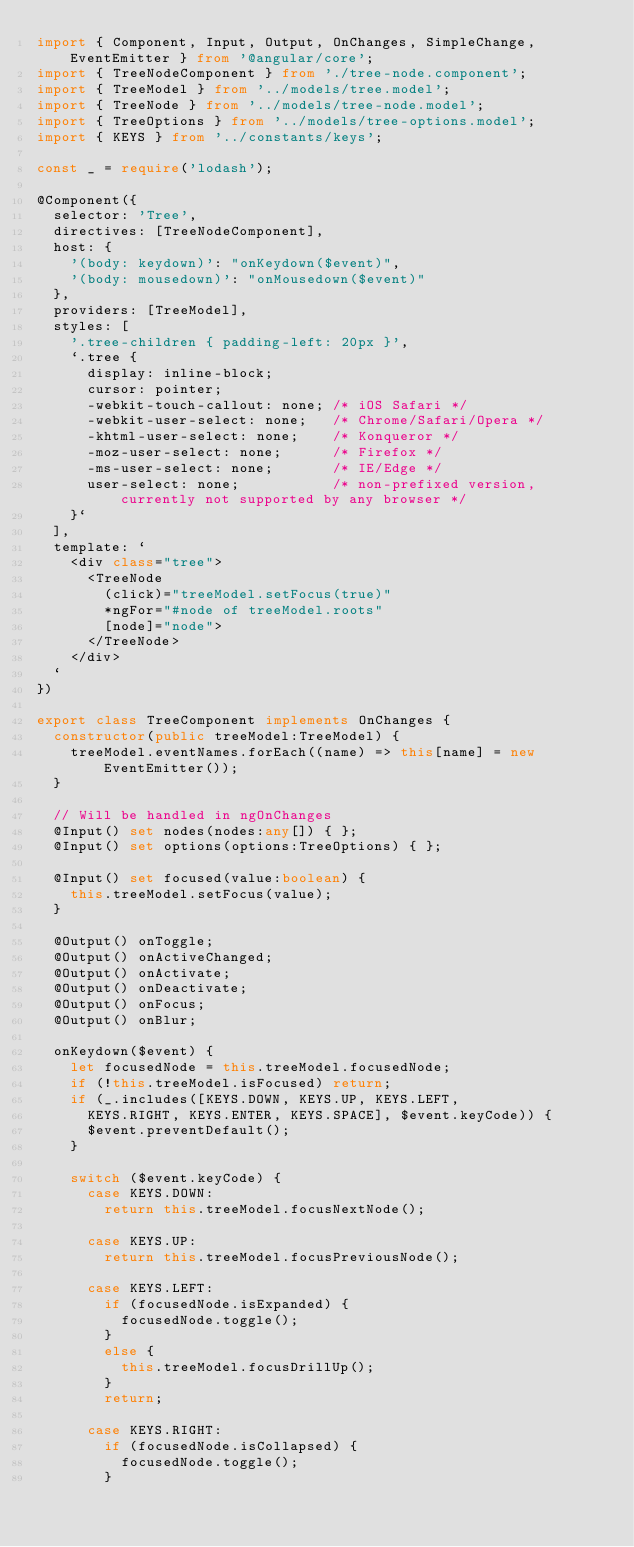Convert code to text. <code><loc_0><loc_0><loc_500><loc_500><_TypeScript_>import { Component, Input, Output, OnChanges, SimpleChange, EventEmitter } from '@angular/core';
import { TreeNodeComponent } from './tree-node.component';
import { TreeModel } from '../models/tree.model';
import { TreeNode } from '../models/tree-node.model';
import { TreeOptions } from '../models/tree-options.model';
import { KEYS } from '../constants/keys';

const _ = require('lodash');

@Component({
  selector: 'Tree',
  directives: [TreeNodeComponent],
  host: {
    '(body: keydown)': "onKeydown($event)",
    '(body: mousedown)': "onMousedown($event)"
  },
  providers: [TreeModel],
  styles: [
    '.tree-children { padding-left: 20px }',
    `.tree {
      display: inline-block;
      cursor: pointer;
      -webkit-touch-callout: none; /* iOS Safari */
      -webkit-user-select: none;   /* Chrome/Safari/Opera */
      -khtml-user-select: none;    /* Konqueror */
      -moz-user-select: none;      /* Firefox */
      -ms-user-select: none;       /* IE/Edge */
      user-select: none;           /* non-prefixed version, currently not supported by any browser */
    }`
  ],
  template: `
    <div class="tree">
      <TreeNode
        (click)="treeModel.setFocus(true)"
        *ngFor="#node of treeModel.roots"
        [node]="node">
      </TreeNode>
    </div>
  `
})

export class TreeComponent implements OnChanges {
  constructor(public treeModel:TreeModel) {
    treeModel.eventNames.forEach((name) => this[name] = new EventEmitter());
  }

  // Will be handled in ngOnChanges
  @Input() set nodes(nodes:any[]) { };
  @Input() set options(options:TreeOptions) { };

  @Input() set focused(value:boolean) {
    this.treeModel.setFocus(value);
  }

  @Output() onToggle;
  @Output() onActiveChanged;
  @Output() onActivate;
  @Output() onDeactivate;
  @Output() onFocus;
  @Output() onBlur;

  onKeydown($event) {
    let focusedNode = this.treeModel.focusedNode;
    if (!this.treeModel.isFocused) return;
    if (_.includes([KEYS.DOWN, KEYS.UP, KEYS.LEFT,
      KEYS.RIGHT, KEYS.ENTER, KEYS.SPACE], $event.keyCode)) {
      $event.preventDefault();
    }

    switch ($event.keyCode) {
      case KEYS.DOWN:
        return this.treeModel.focusNextNode();

      case KEYS.UP:
        return this.treeModel.focusPreviousNode();

      case KEYS.LEFT:
        if (focusedNode.isExpanded) {
          focusedNode.toggle();
        }
        else {
          this.treeModel.focusDrillUp();
        }
        return;

      case KEYS.RIGHT:
        if (focusedNode.isCollapsed) {
          focusedNode.toggle();
        }</code> 